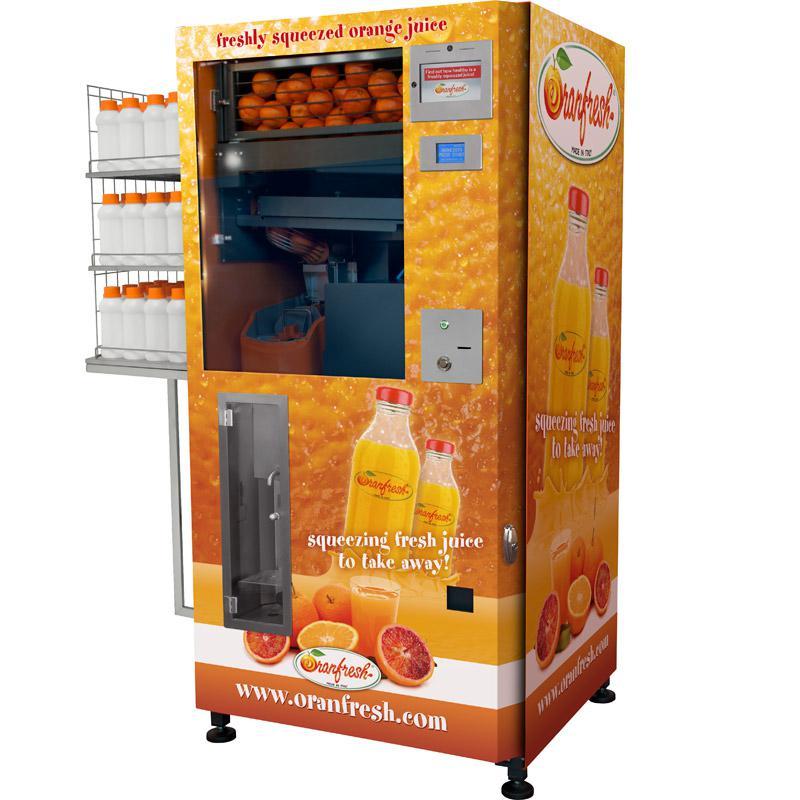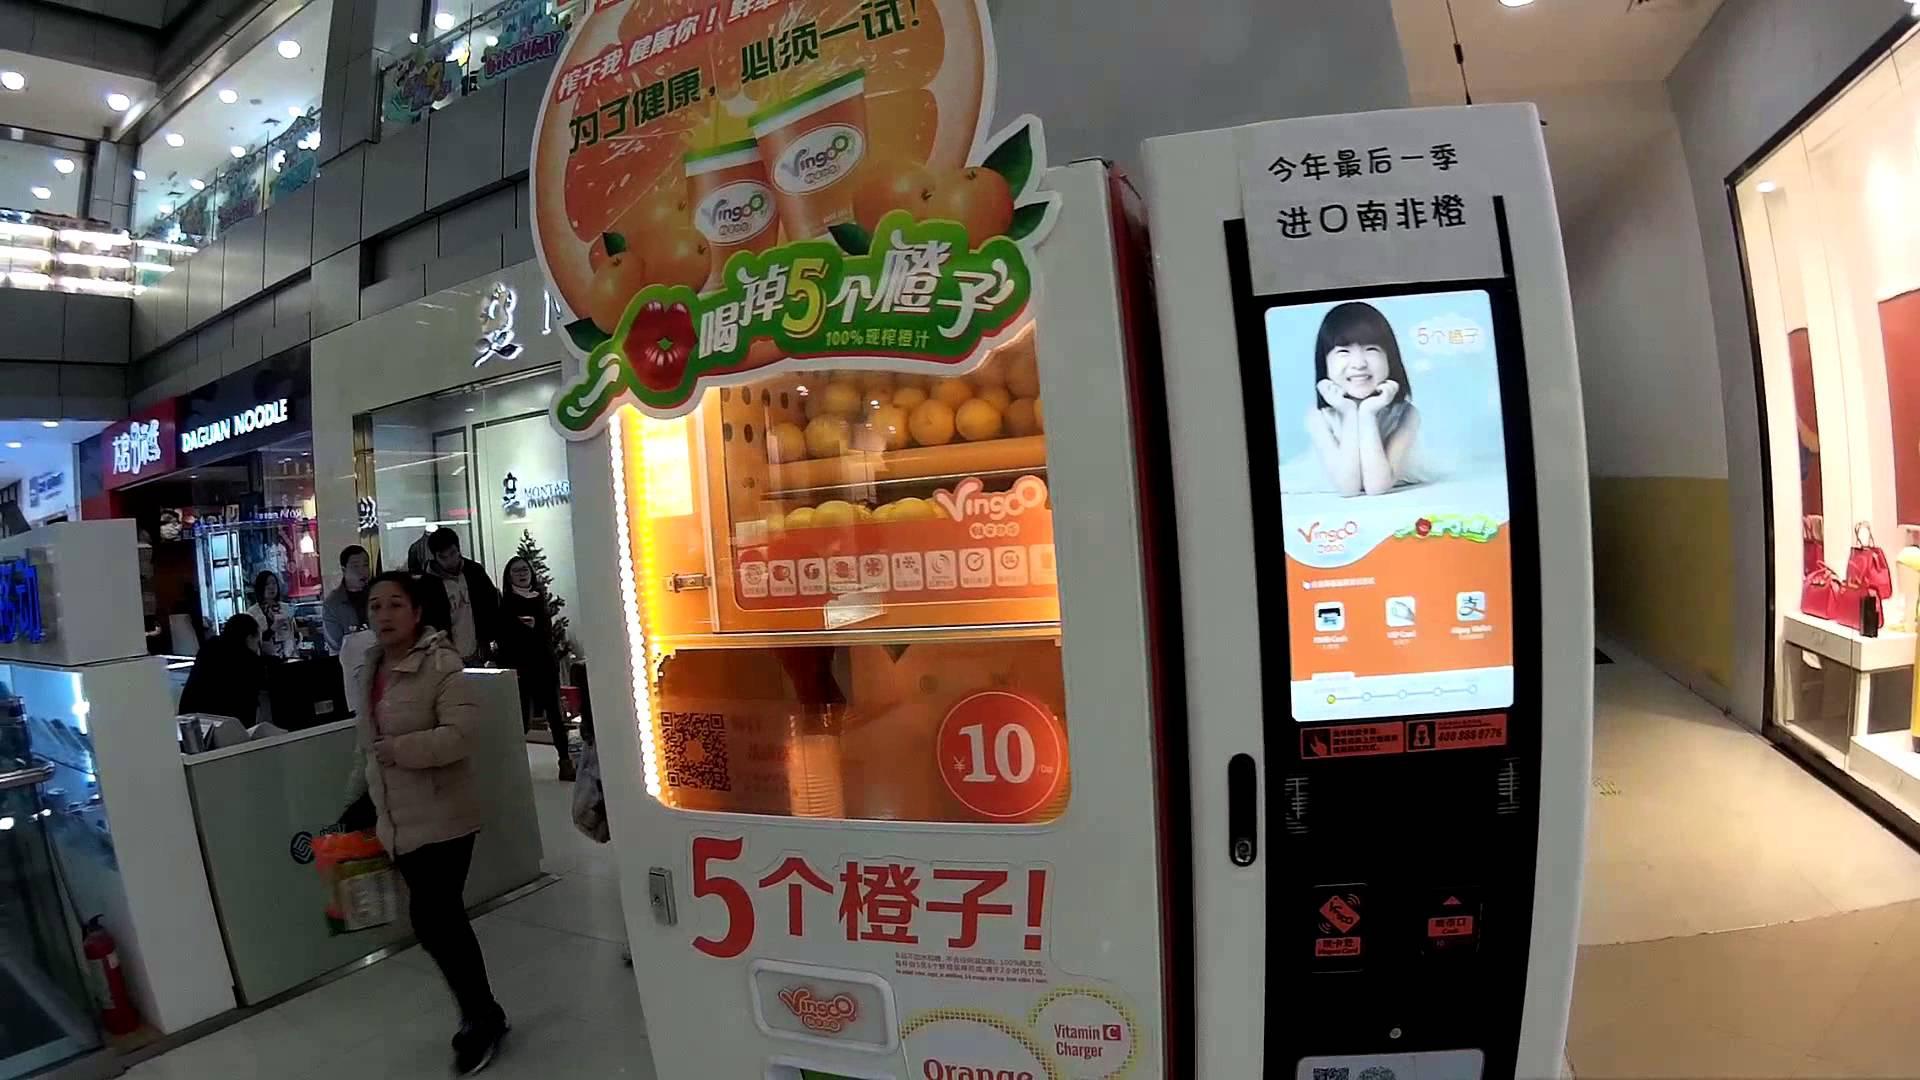The first image is the image on the left, the second image is the image on the right. Assess this claim about the two images: "A human is standing next to a vending machine in one of the images.". Correct or not? Answer yes or no. Yes. The first image is the image on the left, the second image is the image on the right. Assess this claim about the two images: "Real oranges are visible in the top half of all the vending machines, which also feature orange as a major part of their color schemes.". Correct or not? Answer yes or no. Yes. 